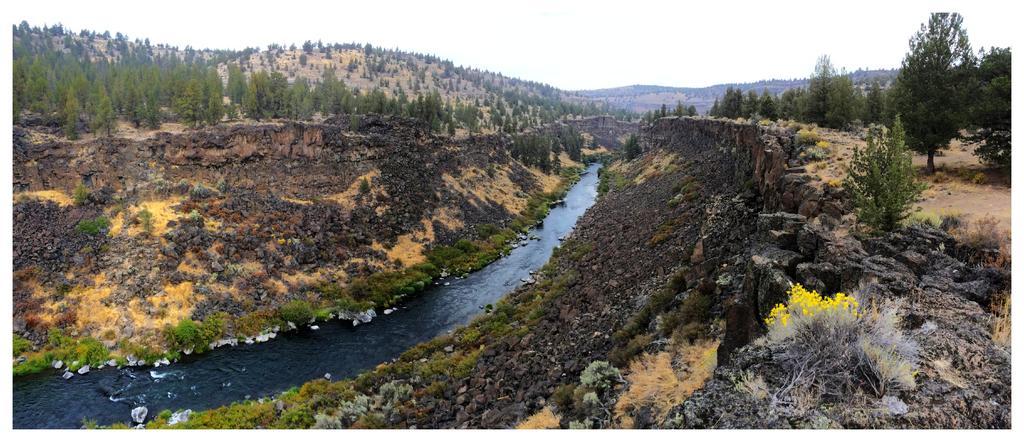Could you give a brief overview of what you see in this image? We can see water,plants,flowers and trees. In the background we can see hills and sky. 